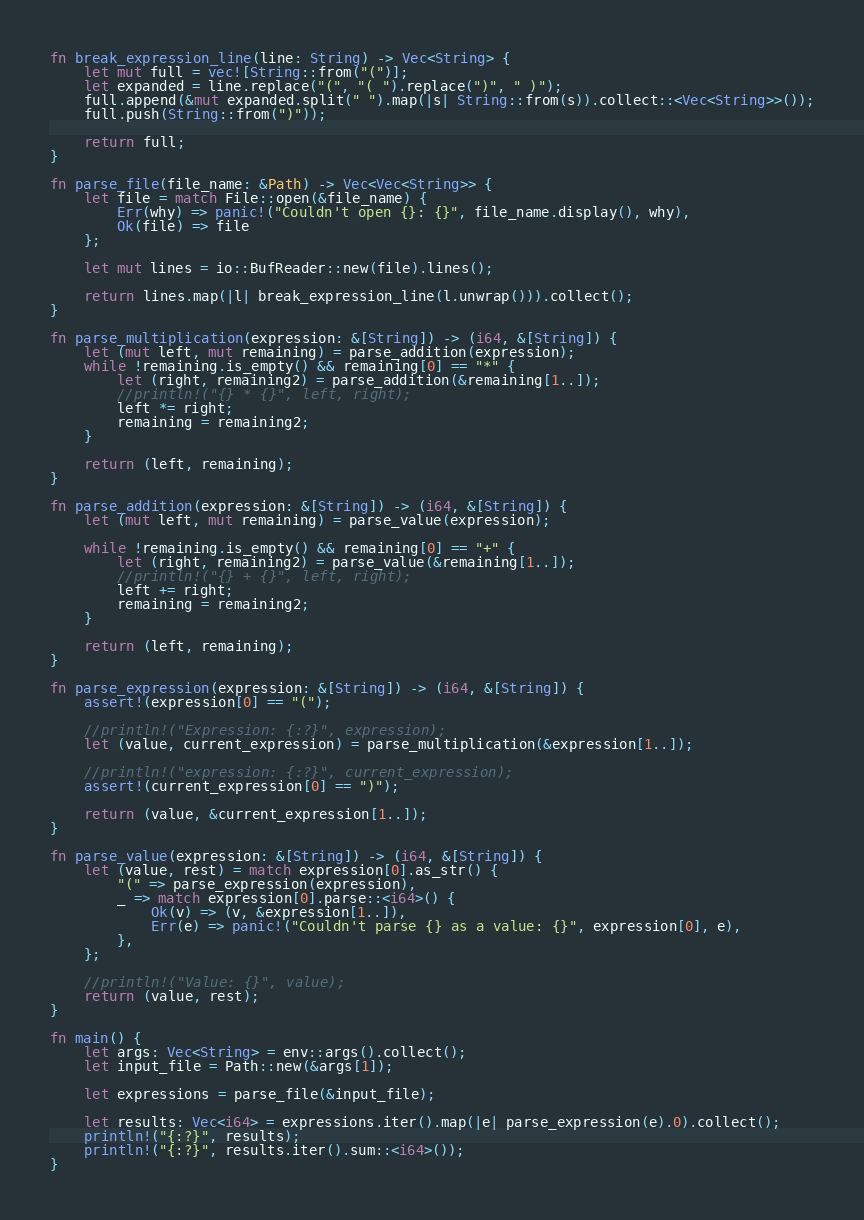<code> <loc_0><loc_0><loc_500><loc_500><_Rust_>fn break_expression_line(line: String) -> Vec<String> {
    let mut full = vec![String::from("(")];
    let expanded = line.replace("(", "( ").replace(")", " )");
    full.append(&mut expanded.split(" ").map(|s| String::from(s)).collect::<Vec<String>>());
    full.push(String::from(")"));

    return full;
} 

fn parse_file(file_name: &Path) -> Vec<Vec<String>> {
    let file = match File::open(&file_name) {
        Err(why) => panic!("Couldn't open {}: {}", file_name.display(), why),
        Ok(file) => file
    };

    let mut lines = io::BufReader::new(file).lines();

    return lines.map(|l| break_expression_line(l.unwrap())).collect();
}

fn parse_multiplication(expression: &[String]) -> (i64, &[String]) {
    let (mut left, mut remaining) = parse_addition(expression);
    while !remaining.is_empty() && remaining[0] == "*" {
        let (right, remaining2) = parse_addition(&remaining[1..]);
        //println!("{} * {}", left, right);
        left *= right;
        remaining = remaining2;
    }

    return (left, remaining);
}

fn parse_addition(expression: &[String]) -> (i64, &[String]) {
    let (mut left, mut remaining) = parse_value(expression);

    while !remaining.is_empty() && remaining[0] == "+" {
        let (right, remaining2) = parse_value(&remaining[1..]);
        //println!("{} + {}", left, right);
        left += right;
        remaining = remaining2;
    }

    return (left, remaining);
}

fn parse_expression(expression: &[String]) -> (i64, &[String]) {
    assert!(expression[0] == "(");

    //println!("Expression: {:?}", expression);
    let (value, current_expression) = parse_multiplication(&expression[1..]);

    //println!("expression: {:?}", current_expression);
    assert!(current_expression[0] == ")");

    return (value, &current_expression[1..]);
}

fn parse_value(expression: &[String]) -> (i64, &[String]) {
    let (value, rest) = match expression[0].as_str() {
        "(" => parse_expression(expression),
        _ => match expression[0].parse::<i64>() {
            Ok(v) => (v, &expression[1..]),
            Err(e) => panic!("Couldn't parse {} as a value: {}", expression[0], e),
        }, 
    };

    //println!("Value: {}", value);
    return (value, rest);
}

fn main() {
    let args: Vec<String> = env::args().collect();
    let input_file = Path::new(&args[1]);

    let expressions = parse_file(&input_file);

    let results: Vec<i64> = expressions.iter().map(|e| parse_expression(e).0).collect();
    println!("{:?}", results);
    println!("{:?}", results.iter().sum::<i64>());
}</code> 